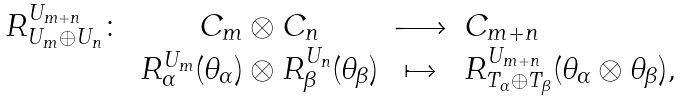Convert formula to latex. <formula><loc_0><loc_0><loc_500><loc_500>\begin{array} { r c c l } R _ { U _ { m } \oplus U _ { n } } ^ { U _ { m + n } } \colon & C _ { m } \otimes C _ { n } & \longrightarrow & C _ { m + n } \\ & R _ { \alpha } ^ { U _ { m } } ( \theta _ { \alpha } ) \otimes R _ { \beta } ^ { U _ { n } } ( \theta _ { \beta } ) & \mapsto & R _ { T _ { \alpha } \oplus T _ { \beta } } ^ { U _ { m + n } } ( \theta _ { \alpha } \otimes \theta _ { \beta } ) , \end{array}</formula> 